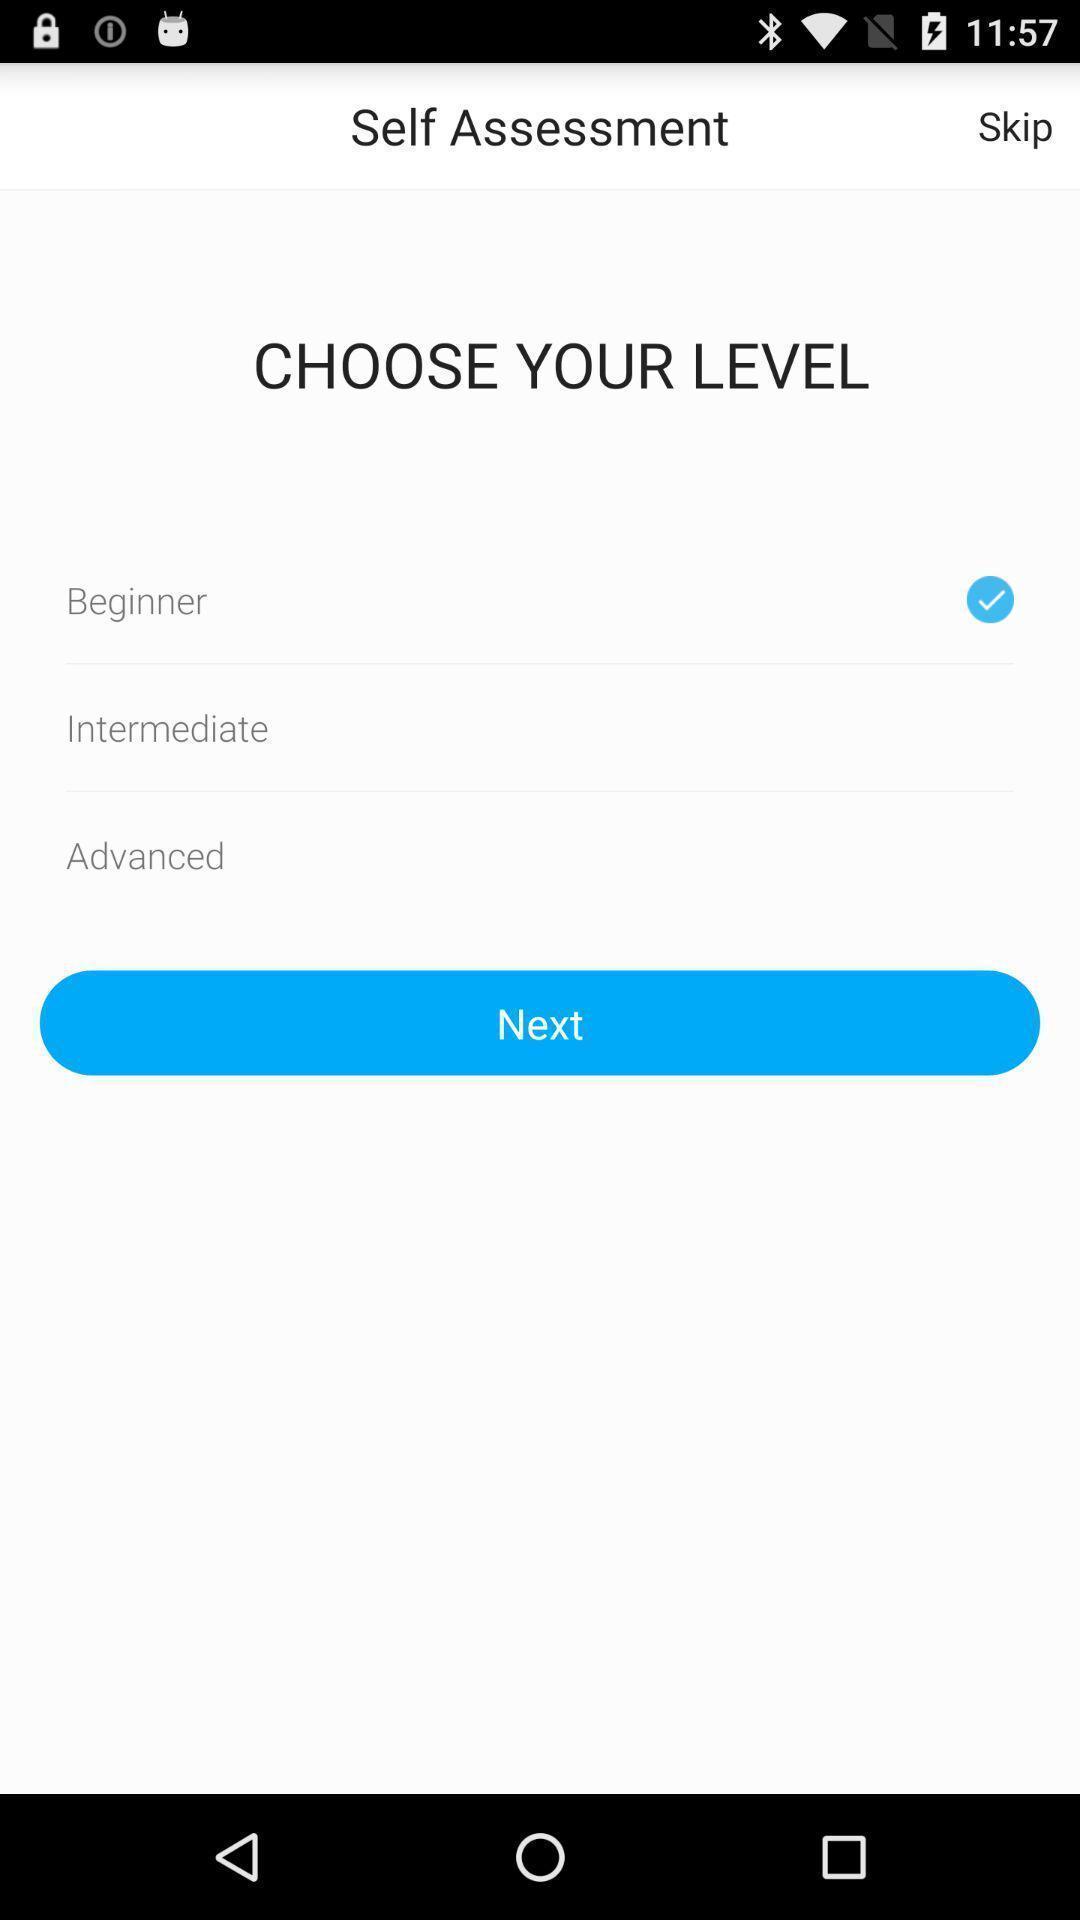Provide a detailed account of this screenshot. Screen shows multiple options in a fitness application. 